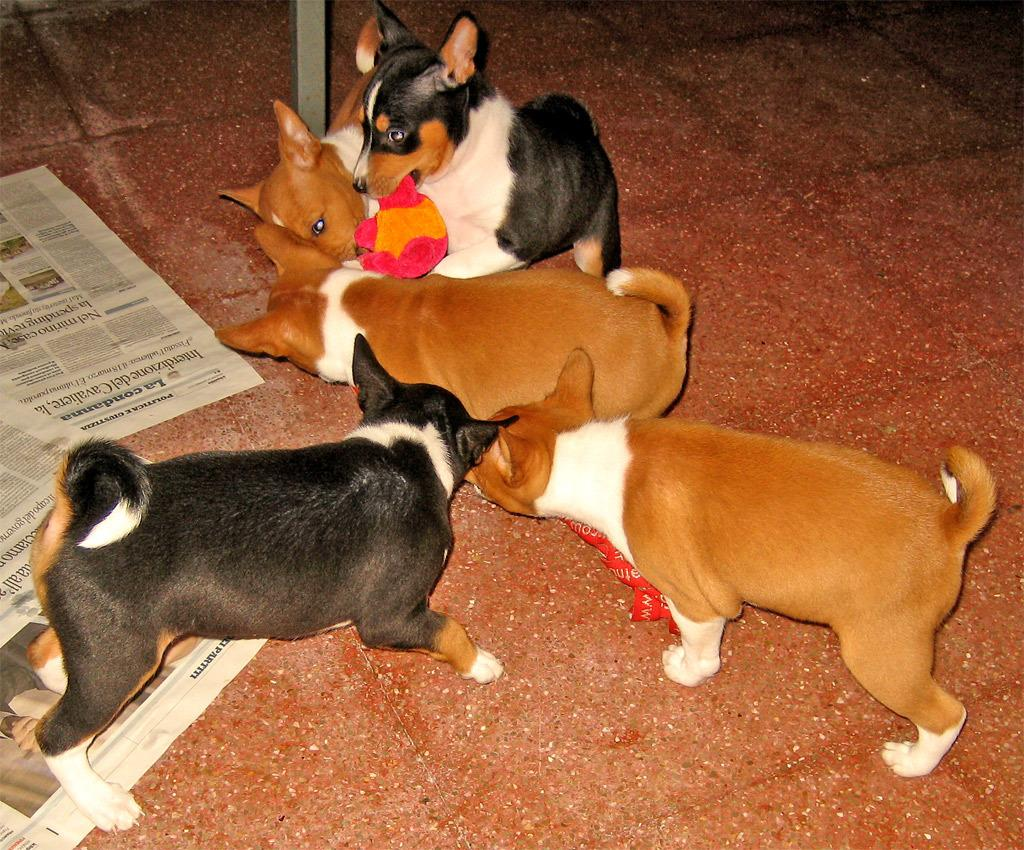What animals are in the center of the image? There are dogs in the center of the image. Where are the dogs located? The dogs are on the floor. What can be seen on the left side of the image? There are newspapers on the left side of the image. What is visible in the background of the image? There is a pole and a floor visible in the background of the image. How many snakes are wrapped around the pole in the background of the image? There are no snakes present in the image; it only features dogs, newspapers, and a pole. What type of lipstick is the dog wearing in the image? Dogs do not wear lipstick, and there is no lipstick present in the image. 